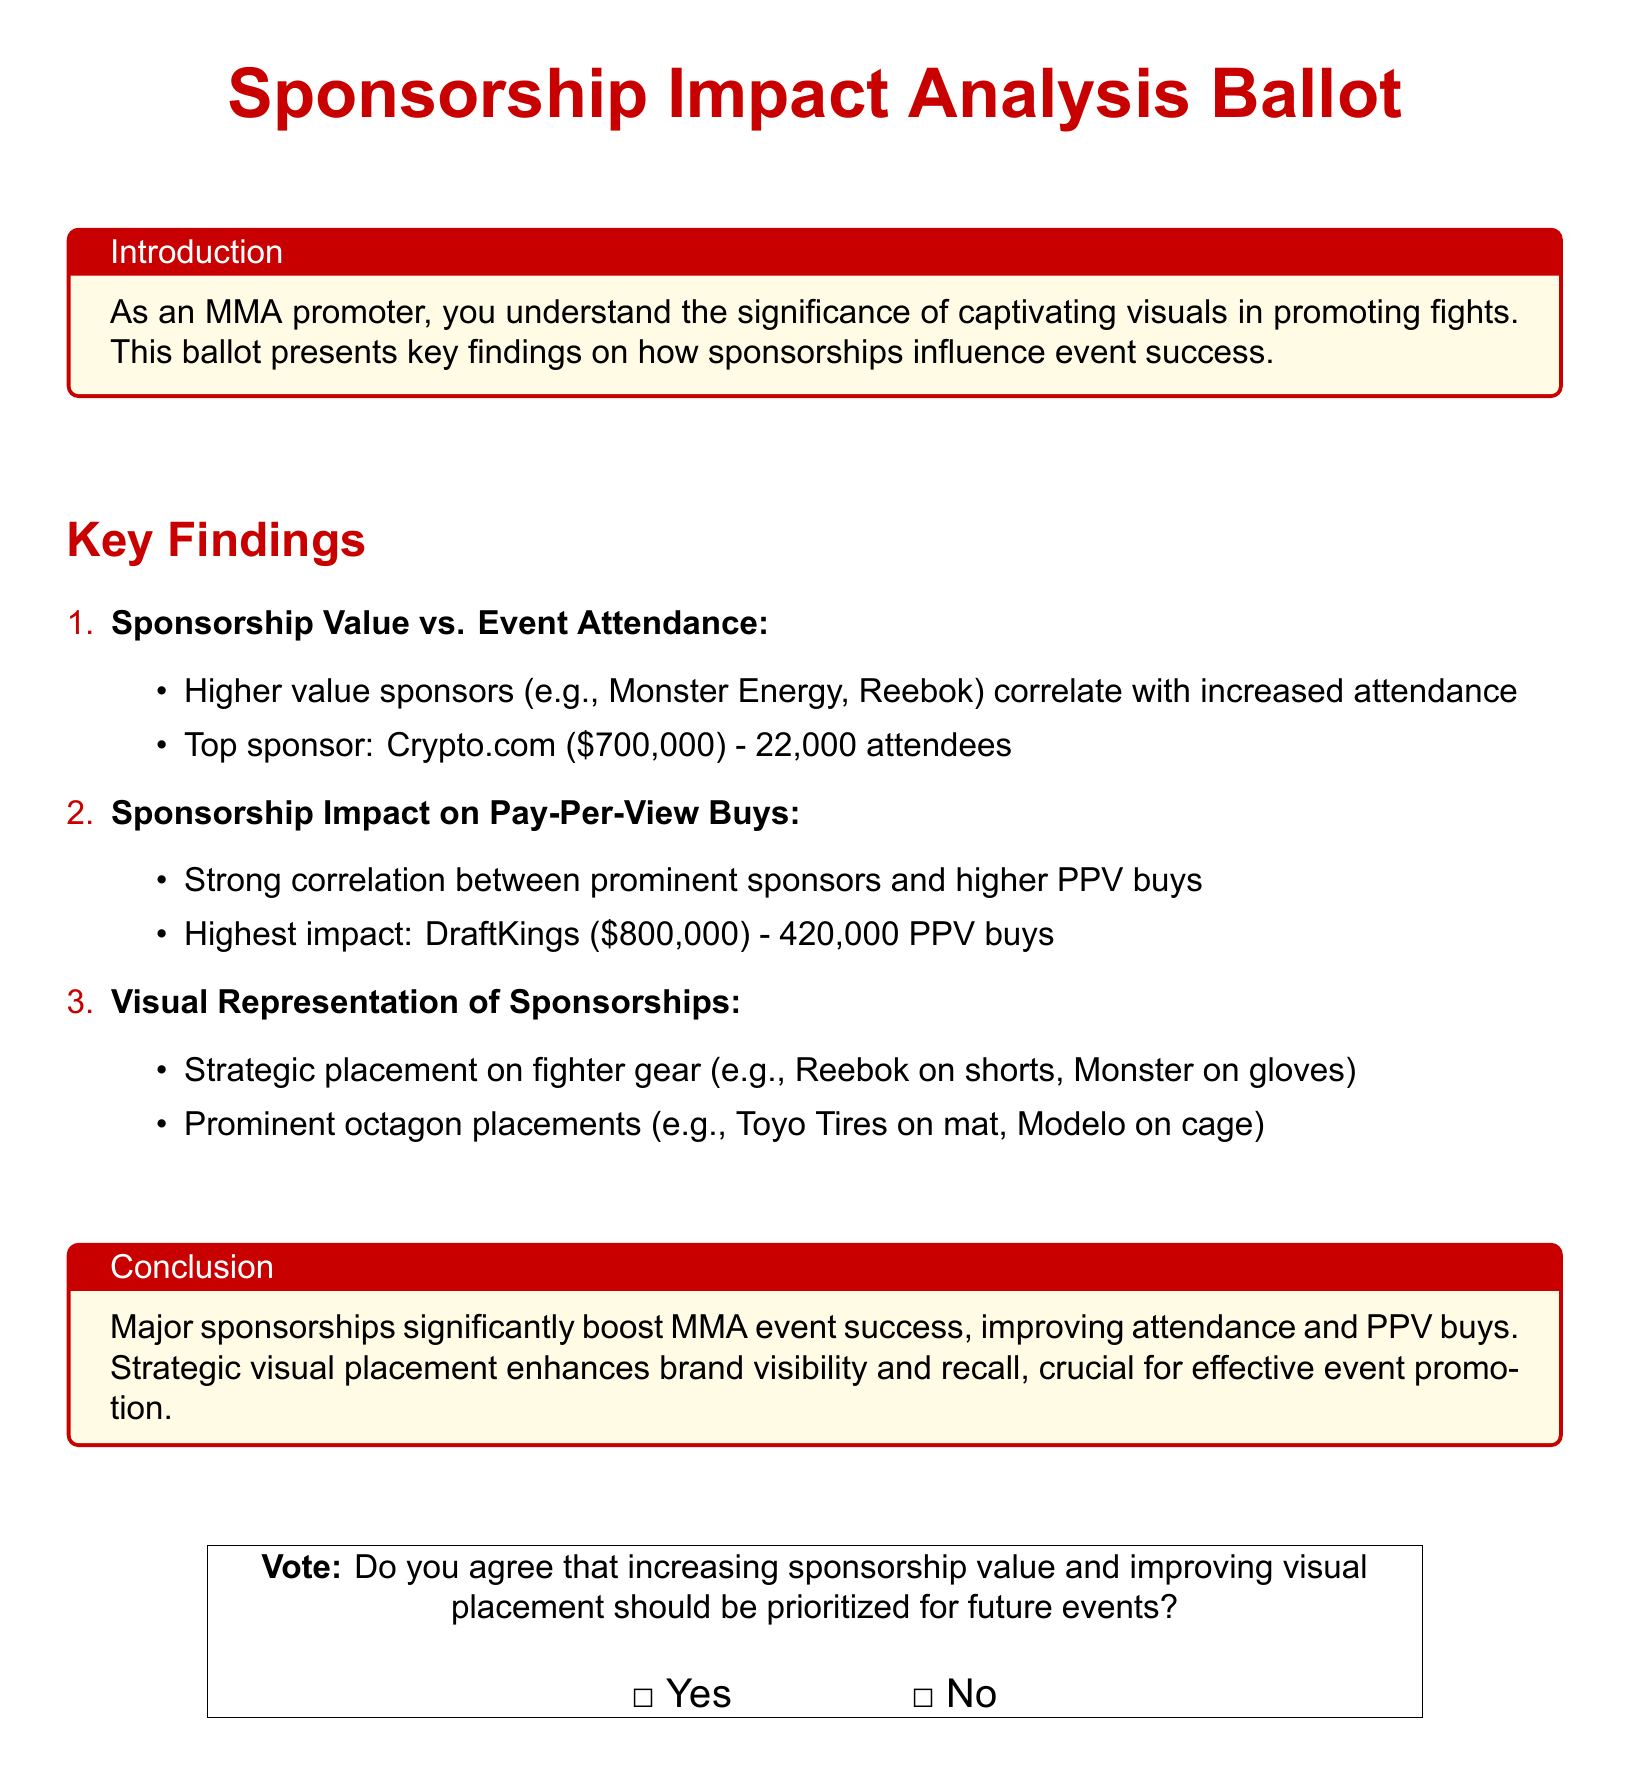What is the title of the ballot? The title of the ballot is prominently displayed at the top and reads "Sponsorship Impact Analysis Ballot."
Answer: Sponsorship Impact Analysis Ballot Who is the top sponsor mentioned in the document? The document specifies that the top sponsor is Crypto.com.
Answer: Crypto.com What is the attendance figure for the top sponsor? The attendance figure for the top sponsor, Crypto.com, is included in the information and states 22,000 attendees.
Answer: 22,000 Which sponsor is associated with the highest pay-per-view buys? The document highlights that DraftKings is associated with the highest PPV buys.
Answer: DraftKings What is the amount spent by the highest impact sponsor? The amount spent by the highest impact sponsor, DraftKings, is stated in the document as $800,000.
Answer: $800,000 How does strategic placement of sponsors impact events? The document notes that strategic placement enhances brand visibility and recall, which improves event promotion.
Answer: Enhances brand visibility and recall In the conclusion, what two main benefits of major sponsorships are emphasized? The conclusion emphasizes that major sponsorships improve attendance and PPV buys.
Answer: Attendance and PPV buys What is the main call to action presented in the ballot? The main call to action invites recipients to vote on prioritizing increasing sponsorship value and visual placement.
Answer: Vote on prioritizing increasing sponsorship value and visual placement What color is used for the title in the document? The color used for the title is specified as mmaRed in the document.
Answer: mmaRed 